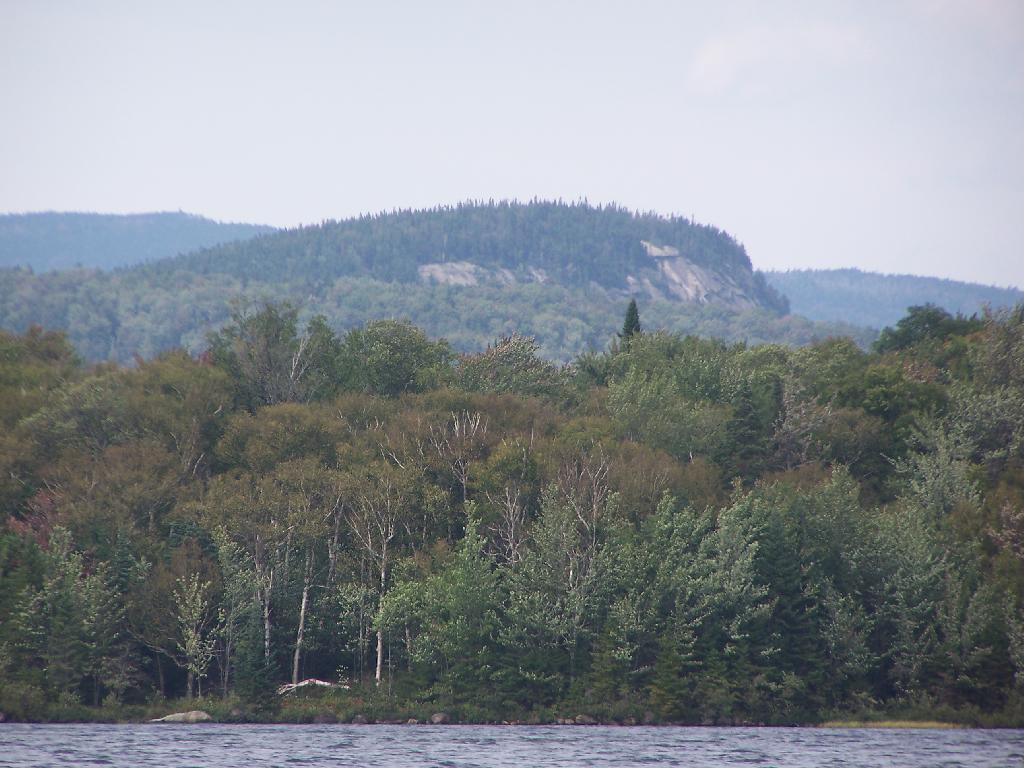What is visible in the image? Water, trees, mountains, and the sky are visible in the image. Can you describe the mountains in the background? The mountains in the background have trees on them. What is the color of the sky in the image? The sky is visible in the background of the image, but the color is not mentioned in the facts. Reasoning: Let's think step by identifying the main subjects and objects in the image based on the provided facts. We then formulate questions that focus on the location and characteristics of these subjects and objects, ensuring that each question can be answered definitively with the information given. We avoid yes/no questions and ensure that the language is simple and clear. Absurd Question/Answer: What type of wine is being served in the image? There is no wine present in the image. How does the image answer the question about the meaning of life? The image does not provide an answer to the question about the meaning of life, as it only shows water, trees, mountains, and the sky. What type of wine is being served in the image? There is no wine present in the image. How does the image answer the question about the meaning of life? The image does not provide an answer to the question about the meaning of life, as it only shows water, trees, mountains, and the sky. 